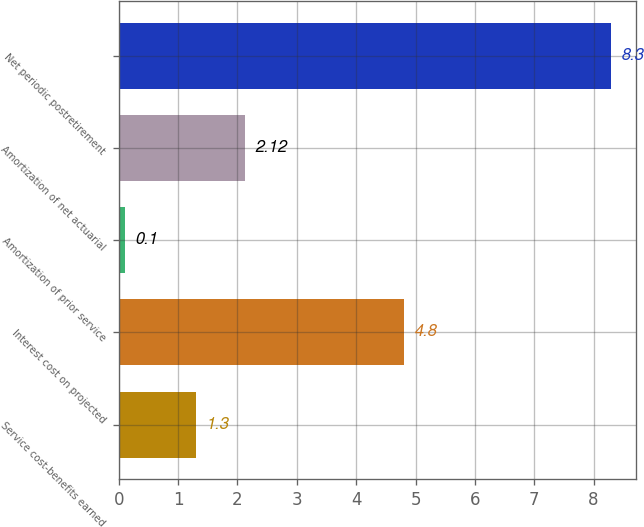<chart> <loc_0><loc_0><loc_500><loc_500><bar_chart><fcel>Service cost-benefits earned<fcel>Interest cost on projected<fcel>Amortization of prior service<fcel>Amortization of net actuarial<fcel>Net periodic postretirement<nl><fcel>1.3<fcel>4.8<fcel>0.1<fcel>2.12<fcel>8.3<nl></chart> 